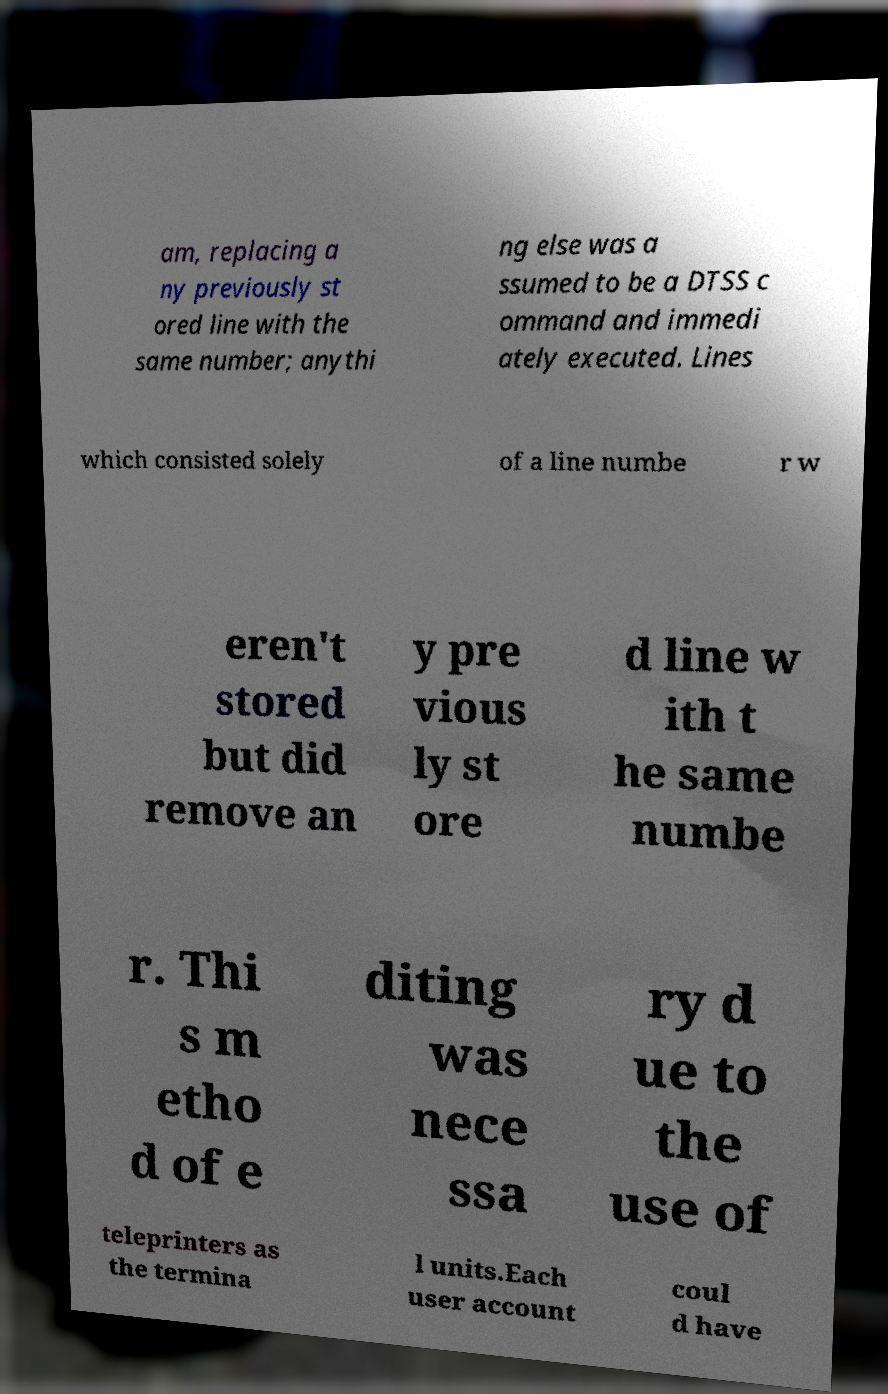For documentation purposes, I need the text within this image transcribed. Could you provide that? am, replacing a ny previously st ored line with the same number; anythi ng else was a ssumed to be a DTSS c ommand and immedi ately executed. Lines which consisted solely of a line numbe r w eren't stored but did remove an y pre vious ly st ore d line w ith t he same numbe r. Thi s m etho d of e diting was nece ssa ry d ue to the use of teleprinters as the termina l units.Each user account coul d have 